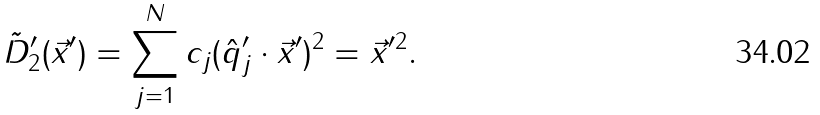<formula> <loc_0><loc_0><loc_500><loc_500>\tilde { D } ^ { \prime } _ { 2 } ( \vec { x } ^ { \prime } ) = \sum _ { j = 1 } ^ { N } c _ { j } ( \hat { q } ^ { \prime } _ { j } \cdot \vec { x } ^ { \prime } ) ^ { 2 } = \| \vec { x } ^ { \prime } \| ^ { 2 } .</formula> 